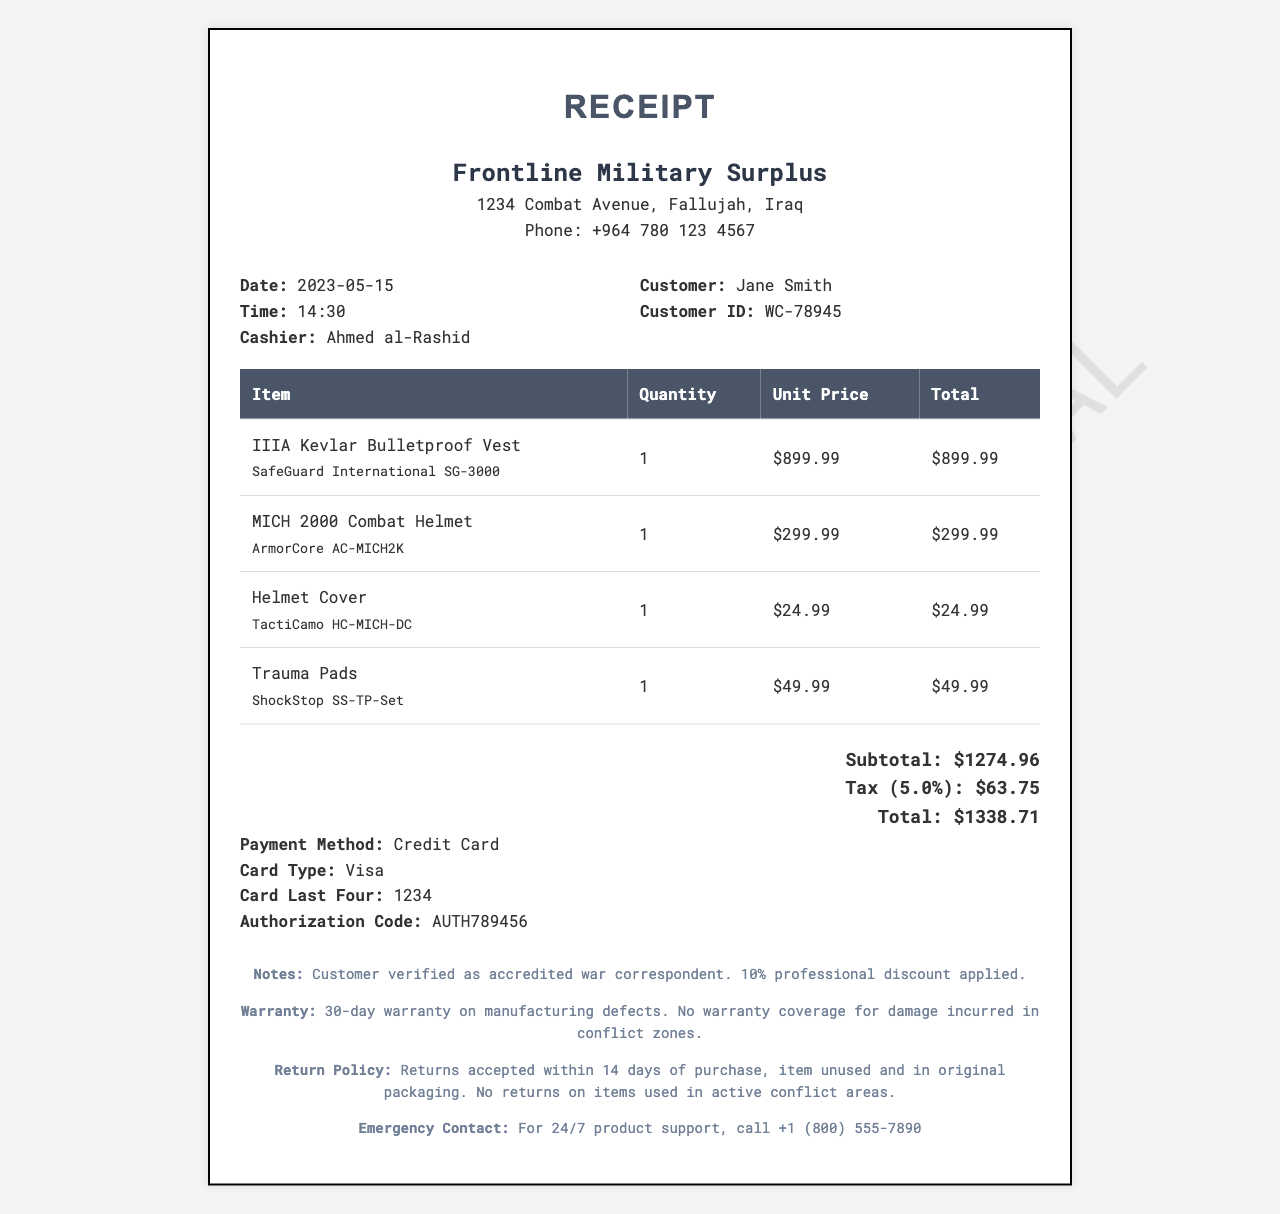What is the store name? The store name is prominently displayed at the top of the receipt.
Answer: Frontline Military Surplus What is the date of purchase? The date of purchase is indicated in the document under the date section.
Answer: 2023-05-15 Who was the cashier? The cashier's name is listed in the receipt details.
Answer: Ahmed al-Rashid What is the total amount paid? The total amount is shown at the end of the receipt in the total section.
Answer: 1338.71 What discount was applied? The notes section mentions the professional discount applied to the customer.
Answer: 10% What is the warranty period for items? The warranty information outlines the duration of coverage for manufacturing defects.
Answer: 30-day warranty What is the return policy for used items? The return policy specifies conditions for returning items.
Answer: No returns on items used in active conflict areas How can customers contact for product support? The emergency contact section provides a telephone number for support inquiries.
Answer: +1 (800) 555-7890 How much tax was applied to the purchase? The tax amount is calculated and presented near the total amount.
Answer: 63.75 